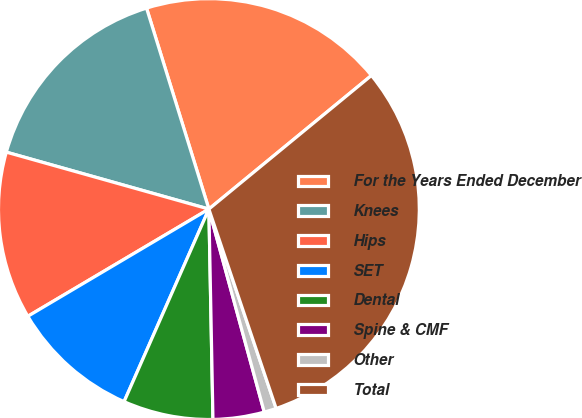Convert chart. <chart><loc_0><loc_0><loc_500><loc_500><pie_chart><fcel>For the Years Ended December<fcel>Knees<fcel>Hips<fcel>SET<fcel>Dental<fcel>Spine & CMF<fcel>Other<fcel>Total<nl><fcel>18.84%<fcel>15.85%<fcel>12.87%<fcel>9.89%<fcel>6.91%<fcel>3.93%<fcel>0.94%<fcel>30.77%<nl></chart> 